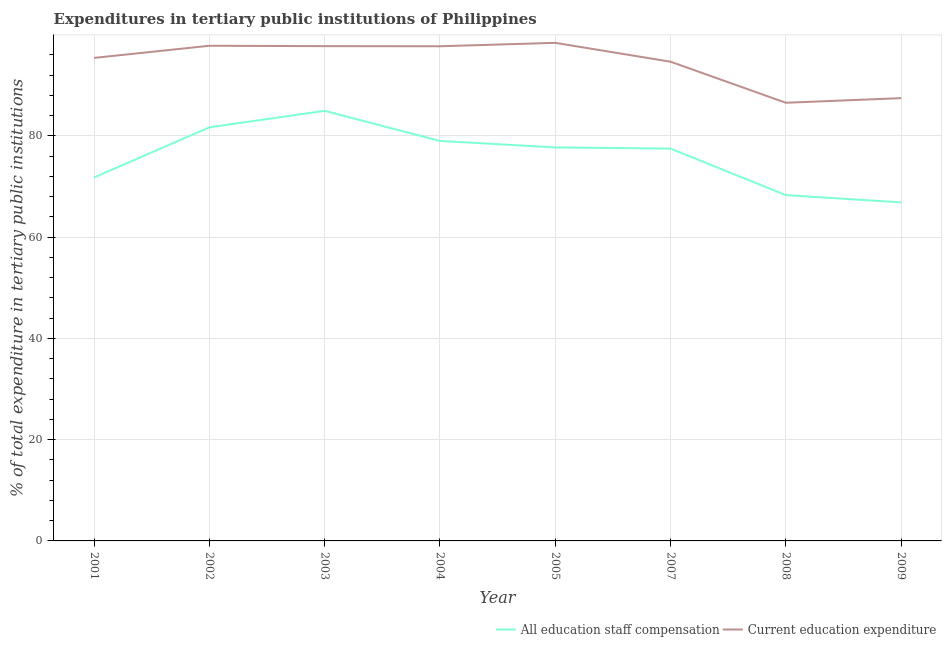Does the line corresponding to expenditure in education intersect with the line corresponding to expenditure in staff compensation?
Provide a succinct answer. No. Is the number of lines equal to the number of legend labels?
Ensure brevity in your answer.  Yes. What is the expenditure in education in 2001?
Your answer should be very brief. 95.41. Across all years, what is the maximum expenditure in education?
Make the answer very short. 98.39. Across all years, what is the minimum expenditure in staff compensation?
Your response must be concise. 66.88. What is the total expenditure in education in the graph?
Provide a short and direct response. 755.74. What is the difference between the expenditure in staff compensation in 2002 and that in 2007?
Keep it short and to the point. 4.2. What is the difference between the expenditure in staff compensation in 2007 and the expenditure in education in 2005?
Ensure brevity in your answer.  -20.89. What is the average expenditure in staff compensation per year?
Your response must be concise. 75.98. In the year 2003, what is the difference between the expenditure in education and expenditure in staff compensation?
Provide a short and direct response. 12.78. What is the ratio of the expenditure in education in 2001 to that in 2005?
Ensure brevity in your answer.  0.97. Is the expenditure in staff compensation in 2002 less than that in 2004?
Provide a succinct answer. No. Is the difference between the expenditure in staff compensation in 2002 and 2003 greater than the difference between the expenditure in education in 2002 and 2003?
Offer a terse response. No. What is the difference between the highest and the second highest expenditure in staff compensation?
Your answer should be very brief. 3.25. What is the difference between the highest and the lowest expenditure in education?
Offer a terse response. 11.84. Is the sum of the expenditure in education in 2004 and 2009 greater than the maximum expenditure in staff compensation across all years?
Your response must be concise. Yes. Does the expenditure in education monotonically increase over the years?
Ensure brevity in your answer.  No. Is the expenditure in education strictly greater than the expenditure in staff compensation over the years?
Your response must be concise. Yes. How many lines are there?
Your answer should be very brief. 2. How many years are there in the graph?
Provide a succinct answer. 8. What is the difference between two consecutive major ticks on the Y-axis?
Ensure brevity in your answer.  20. Are the values on the major ticks of Y-axis written in scientific E-notation?
Offer a terse response. No. Does the graph contain any zero values?
Ensure brevity in your answer.  No. What is the title of the graph?
Provide a succinct answer. Expenditures in tertiary public institutions of Philippines. Does "Working capital" appear as one of the legend labels in the graph?
Keep it short and to the point. No. What is the label or title of the Y-axis?
Make the answer very short. % of total expenditure in tertiary public institutions. What is the % of total expenditure in tertiary public institutions of All education staff compensation in 2001?
Your response must be concise. 71.79. What is the % of total expenditure in tertiary public institutions of Current education expenditure in 2001?
Keep it short and to the point. 95.41. What is the % of total expenditure in tertiary public institutions in All education staff compensation in 2002?
Your answer should be compact. 81.7. What is the % of total expenditure in tertiary public institutions of Current education expenditure in 2002?
Ensure brevity in your answer.  97.81. What is the % of total expenditure in tertiary public institutions in All education staff compensation in 2003?
Provide a succinct answer. 84.95. What is the % of total expenditure in tertiary public institutions in Current education expenditure in 2003?
Offer a terse response. 97.74. What is the % of total expenditure in tertiary public institutions of All education staff compensation in 2004?
Give a very brief answer. 79.01. What is the % of total expenditure in tertiary public institutions in Current education expenditure in 2004?
Ensure brevity in your answer.  97.72. What is the % of total expenditure in tertiary public institutions of All education staff compensation in 2005?
Give a very brief answer. 77.73. What is the % of total expenditure in tertiary public institutions of Current education expenditure in 2005?
Provide a short and direct response. 98.39. What is the % of total expenditure in tertiary public institutions in All education staff compensation in 2007?
Your answer should be compact. 77.5. What is the % of total expenditure in tertiary public institutions in Current education expenditure in 2007?
Offer a terse response. 94.66. What is the % of total expenditure in tertiary public institutions in All education staff compensation in 2008?
Offer a very short reply. 68.31. What is the % of total expenditure in tertiary public institutions of Current education expenditure in 2008?
Your response must be concise. 86.55. What is the % of total expenditure in tertiary public institutions in All education staff compensation in 2009?
Keep it short and to the point. 66.88. What is the % of total expenditure in tertiary public institutions of Current education expenditure in 2009?
Make the answer very short. 87.46. Across all years, what is the maximum % of total expenditure in tertiary public institutions in All education staff compensation?
Your answer should be very brief. 84.95. Across all years, what is the maximum % of total expenditure in tertiary public institutions in Current education expenditure?
Keep it short and to the point. 98.39. Across all years, what is the minimum % of total expenditure in tertiary public institutions of All education staff compensation?
Your response must be concise. 66.88. Across all years, what is the minimum % of total expenditure in tertiary public institutions in Current education expenditure?
Make the answer very short. 86.55. What is the total % of total expenditure in tertiary public institutions of All education staff compensation in the graph?
Your answer should be very brief. 607.87. What is the total % of total expenditure in tertiary public institutions in Current education expenditure in the graph?
Your answer should be compact. 755.74. What is the difference between the % of total expenditure in tertiary public institutions of All education staff compensation in 2001 and that in 2002?
Make the answer very short. -9.91. What is the difference between the % of total expenditure in tertiary public institutions of Current education expenditure in 2001 and that in 2002?
Your answer should be compact. -2.4. What is the difference between the % of total expenditure in tertiary public institutions in All education staff compensation in 2001 and that in 2003?
Your answer should be compact. -13.16. What is the difference between the % of total expenditure in tertiary public institutions in Current education expenditure in 2001 and that in 2003?
Keep it short and to the point. -2.32. What is the difference between the % of total expenditure in tertiary public institutions in All education staff compensation in 2001 and that in 2004?
Your answer should be compact. -7.22. What is the difference between the % of total expenditure in tertiary public institutions in Current education expenditure in 2001 and that in 2004?
Provide a short and direct response. -2.3. What is the difference between the % of total expenditure in tertiary public institutions of All education staff compensation in 2001 and that in 2005?
Ensure brevity in your answer.  -5.94. What is the difference between the % of total expenditure in tertiary public institutions of Current education expenditure in 2001 and that in 2005?
Your response must be concise. -2.97. What is the difference between the % of total expenditure in tertiary public institutions of All education staff compensation in 2001 and that in 2007?
Provide a succinct answer. -5.71. What is the difference between the % of total expenditure in tertiary public institutions in Current education expenditure in 2001 and that in 2007?
Your response must be concise. 0.75. What is the difference between the % of total expenditure in tertiary public institutions of All education staff compensation in 2001 and that in 2008?
Make the answer very short. 3.48. What is the difference between the % of total expenditure in tertiary public institutions in Current education expenditure in 2001 and that in 2008?
Your answer should be very brief. 8.86. What is the difference between the % of total expenditure in tertiary public institutions of All education staff compensation in 2001 and that in 2009?
Provide a succinct answer. 4.92. What is the difference between the % of total expenditure in tertiary public institutions in Current education expenditure in 2001 and that in 2009?
Your answer should be very brief. 7.95. What is the difference between the % of total expenditure in tertiary public institutions of All education staff compensation in 2002 and that in 2003?
Provide a succinct answer. -3.25. What is the difference between the % of total expenditure in tertiary public institutions of Current education expenditure in 2002 and that in 2003?
Provide a succinct answer. 0.07. What is the difference between the % of total expenditure in tertiary public institutions of All education staff compensation in 2002 and that in 2004?
Provide a succinct answer. 2.69. What is the difference between the % of total expenditure in tertiary public institutions of Current education expenditure in 2002 and that in 2004?
Offer a terse response. 0.09. What is the difference between the % of total expenditure in tertiary public institutions in All education staff compensation in 2002 and that in 2005?
Your answer should be very brief. 3.97. What is the difference between the % of total expenditure in tertiary public institutions in Current education expenditure in 2002 and that in 2005?
Provide a succinct answer. -0.58. What is the difference between the % of total expenditure in tertiary public institutions of All education staff compensation in 2002 and that in 2007?
Make the answer very short. 4.2. What is the difference between the % of total expenditure in tertiary public institutions of Current education expenditure in 2002 and that in 2007?
Ensure brevity in your answer.  3.15. What is the difference between the % of total expenditure in tertiary public institutions of All education staff compensation in 2002 and that in 2008?
Offer a terse response. 13.39. What is the difference between the % of total expenditure in tertiary public institutions in Current education expenditure in 2002 and that in 2008?
Your answer should be very brief. 11.26. What is the difference between the % of total expenditure in tertiary public institutions in All education staff compensation in 2002 and that in 2009?
Provide a short and direct response. 14.83. What is the difference between the % of total expenditure in tertiary public institutions in Current education expenditure in 2002 and that in 2009?
Your answer should be very brief. 10.35. What is the difference between the % of total expenditure in tertiary public institutions in All education staff compensation in 2003 and that in 2004?
Offer a terse response. 5.94. What is the difference between the % of total expenditure in tertiary public institutions in Current education expenditure in 2003 and that in 2004?
Your response must be concise. 0.02. What is the difference between the % of total expenditure in tertiary public institutions in All education staff compensation in 2003 and that in 2005?
Make the answer very short. 7.23. What is the difference between the % of total expenditure in tertiary public institutions of Current education expenditure in 2003 and that in 2005?
Give a very brief answer. -0.65. What is the difference between the % of total expenditure in tertiary public institutions of All education staff compensation in 2003 and that in 2007?
Provide a succinct answer. 7.46. What is the difference between the % of total expenditure in tertiary public institutions of Current education expenditure in 2003 and that in 2007?
Your answer should be very brief. 3.07. What is the difference between the % of total expenditure in tertiary public institutions of All education staff compensation in 2003 and that in 2008?
Offer a very short reply. 16.65. What is the difference between the % of total expenditure in tertiary public institutions of Current education expenditure in 2003 and that in 2008?
Offer a very short reply. 11.19. What is the difference between the % of total expenditure in tertiary public institutions in All education staff compensation in 2003 and that in 2009?
Give a very brief answer. 18.08. What is the difference between the % of total expenditure in tertiary public institutions of Current education expenditure in 2003 and that in 2009?
Ensure brevity in your answer.  10.27. What is the difference between the % of total expenditure in tertiary public institutions of All education staff compensation in 2004 and that in 2005?
Your response must be concise. 1.28. What is the difference between the % of total expenditure in tertiary public institutions of Current education expenditure in 2004 and that in 2005?
Your answer should be compact. -0.67. What is the difference between the % of total expenditure in tertiary public institutions in All education staff compensation in 2004 and that in 2007?
Offer a terse response. 1.52. What is the difference between the % of total expenditure in tertiary public institutions of Current education expenditure in 2004 and that in 2007?
Give a very brief answer. 3.05. What is the difference between the % of total expenditure in tertiary public institutions of All education staff compensation in 2004 and that in 2008?
Provide a short and direct response. 10.71. What is the difference between the % of total expenditure in tertiary public institutions of Current education expenditure in 2004 and that in 2008?
Offer a very short reply. 11.17. What is the difference between the % of total expenditure in tertiary public institutions in All education staff compensation in 2004 and that in 2009?
Ensure brevity in your answer.  12.14. What is the difference between the % of total expenditure in tertiary public institutions in Current education expenditure in 2004 and that in 2009?
Ensure brevity in your answer.  10.25. What is the difference between the % of total expenditure in tertiary public institutions in All education staff compensation in 2005 and that in 2007?
Your response must be concise. 0.23. What is the difference between the % of total expenditure in tertiary public institutions of Current education expenditure in 2005 and that in 2007?
Your response must be concise. 3.72. What is the difference between the % of total expenditure in tertiary public institutions in All education staff compensation in 2005 and that in 2008?
Offer a terse response. 9.42. What is the difference between the % of total expenditure in tertiary public institutions in Current education expenditure in 2005 and that in 2008?
Your response must be concise. 11.84. What is the difference between the % of total expenditure in tertiary public institutions of All education staff compensation in 2005 and that in 2009?
Your answer should be very brief. 10.85. What is the difference between the % of total expenditure in tertiary public institutions of Current education expenditure in 2005 and that in 2009?
Provide a short and direct response. 10.92. What is the difference between the % of total expenditure in tertiary public institutions of All education staff compensation in 2007 and that in 2008?
Provide a short and direct response. 9.19. What is the difference between the % of total expenditure in tertiary public institutions in Current education expenditure in 2007 and that in 2008?
Ensure brevity in your answer.  8.11. What is the difference between the % of total expenditure in tertiary public institutions of All education staff compensation in 2007 and that in 2009?
Offer a very short reply. 10.62. What is the difference between the % of total expenditure in tertiary public institutions of Current education expenditure in 2007 and that in 2009?
Your answer should be very brief. 7.2. What is the difference between the % of total expenditure in tertiary public institutions in All education staff compensation in 2008 and that in 2009?
Give a very brief answer. 1.43. What is the difference between the % of total expenditure in tertiary public institutions in Current education expenditure in 2008 and that in 2009?
Make the answer very short. -0.91. What is the difference between the % of total expenditure in tertiary public institutions in All education staff compensation in 2001 and the % of total expenditure in tertiary public institutions in Current education expenditure in 2002?
Your answer should be very brief. -26.02. What is the difference between the % of total expenditure in tertiary public institutions in All education staff compensation in 2001 and the % of total expenditure in tertiary public institutions in Current education expenditure in 2003?
Give a very brief answer. -25.94. What is the difference between the % of total expenditure in tertiary public institutions in All education staff compensation in 2001 and the % of total expenditure in tertiary public institutions in Current education expenditure in 2004?
Your answer should be very brief. -25.92. What is the difference between the % of total expenditure in tertiary public institutions in All education staff compensation in 2001 and the % of total expenditure in tertiary public institutions in Current education expenditure in 2005?
Make the answer very short. -26.59. What is the difference between the % of total expenditure in tertiary public institutions of All education staff compensation in 2001 and the % of total expenditure in tertiary public institutions of Current education expenditure in 2007?
Provide a succinct answer. -22.87. What is the difference between the % of total expenditure in tertiary public institutions in All education staff compensation in 2001 and the % of total expenditure in tertiary public institutions in Current education expenditure in 2008?
Offer a very short reply. -14.76. What is the difference between the % of total expenditure in tertiary public institutions of All education staff compensation in 2001 and the % of total expenditure in tertiary public institutions of Current education expenditure in 2009?
Your response must be concise. -15.67. What is the difference between the % of total expenditure in tertiary public institutions in All education staff compensation in 2002 and the % of total expenditure in tertiary public institutions in Current education expenditure in 2003?
Your response must be concise. -16.04. What is the difference between the % of total expenditure in tertiary public institutions in All education staff compensation in 2002 and the % of total expenditure in tertiary public institutions in Current education expenditure in 2004?
Offer a terse response. -16.01. What is the difference between the % of total expenditure in tertiary public institutions of All education staff compensation in 2002 and the % of total expenditure in tertiary public institutions of Current education expenditure in 2005?
Your answer should be very brief. -16.68. What is the difference between the % of total expenditure in tertiary public institutions of All education staff compensation in 2002 and the % of total expenditure in tertiary public institutions of Current education expenditure in 2007?
Your answer should be very brief. -12.96. What is the difference between the % of total expenditure in tertiary public institutions of All education staff compensation in 2002 and the % of total expenditure in tertiary public institutions of Current education expenditure in 2008?
Your response must be concise. -4.85. What is the difference between the % of total expenditure in tertiary public institutions of All education staff compensation in 2002 and the % of total expenditure in tertiary public institutions of Current education expenditure in 2009?
Keep it short and to the point. -5.76. What is the difference between the % of total expenditure in tertiary public institutions of All education staff compensation in 2003 and the % of total expenditure in tertiary public institutions of Current education expenditure in 2004?
Your answer should be very brief. -12.76. What is the difference between the % of total expenditure in tertiary public institutions in All education staff compensation in 2003 and the % of total expenditure in tertiary public institutions in Current education expenditure in 2005?
Offer a very short reply. -13.43. What is the difference between the % of total expenditure in tertiary public institutions in All education staff compensation in 2003 and the % of total expenditure in tertiary public institutions in Current education expenditure in 2007?
Offer a very short reply. -9.71. What is the difference between the % of total expenditure in tertiary public institutions in All education staff compensation in 2003 and the % of total expenditure in tertiary public institutions in Current education expenditure in 2008?
Your answer should be compact. -1.6. What is the difference between the % of total expenditure in tertiary public institutions in All education staff compensation in 2003 and the % of total expenditure in tertiary public institutions in Current education expenditure in 2009?
Your response must be concise. -2.51. What is the difference between the % of total expenditure in tertiary public institutions in All education staff compensation in 2004 and the % of total expenditure in tertiary public institutions in Current education expenditure in 2005?
Keep it short and to the point. -19.37. What is the difference between the % of total expenditure in tertiary public institutions in All education staff compensation in 2004 and the % of total expenditure in tertiary public institutions in Current education expenditure in 2007?
Ensure brevity in your answer.  -15.65. What is the difference between the % of total expenditure in tertiary public institutions in All education staff compensation in 2004 and the % of total expenditure in tertiary public institutions in Current education expenditure in 2008?
Make the answer very short. -7.54. What is the difference between the % of total expenditure in tertiary public institutions in All education staff compensation in 2004 and the % of total expenditure in tertiary public institutions in Current education expenditure in 2009?
Your answer should be compact. -8.45. What is the difference between the % of total expenditure in tertiary public institutions of All education staff compensation in 2005 and the % of total expenditure in tertiary public institutions of Current education expenditure in 2007?
Your answer should be compact. -16.93. What is the difference between the % of total expenditure in tertiary public institutions of All education staff compensation in 2005 and the % of total expenditure in tertiary public institutions of Current education expenditure in 2008?
Provide a succinct answer. -8.82. What is the difference between the % of total expenditure in tertiary public institutions of All education staff compensation in 2005 and the % of total expenditure in tertiary public institutions of Current education expenditure in 2009?
Your response must be concise. -9.74. What is the difference between the % of total expenditure in tertiary public institutions in All education staff compensation in 2007 and the % of total expenditure in tertiary public institutions in Current education expenditure in 2008?
Provide a succinct answer. -9.05. What is the difference between the % of total expenditure in tertiary public institutions of All education staff compensation in 2007 and the % of total expenditure in tertiary public institutions of Current education expenditure in 2009?
Offer a terse response. -9.97. What is the difference between the % of total expenditure in tertiary public institutions in All education staff compensation in 2008 and the % of total expenditure in tertiary public institutions in Current education expenditure in 2009?
Offer a terse response. -19.16. What is the average % of total expenditure in tertiary public institutions in All education staff compensation per year?
Give a very brief answer. 75.98. What is the average % of total expenditure in tertiary public institutions of Current education expenditure per year?
Make the answer very short. 94.47. In the year 2001, what is the difference between the % of total expenditure in tertiary public institutions of All education staff compensation and % of total expenditure in tertiary public institutions of Current education expenditure?
Give a very brief answer. -23.62. In the year 2002, what is the difference between the % of total expenditure in tertiary public institutions in All education staff compensation and % of total expenditure in tertiary public institutions in Current education expenditure?
Offer a terse response. -16.11. In the year 2003, what is the difference between the % of total expenditure in tertiary public institutions in All education staff compensation and % of total expenditure in tertiary public institutions in Current education expenditure?
Give a very brief answer. -12.78. In the year 2004, what is the difference between the % of total expenditure in tertiary public institutions of All education staff compensation and % of total expenditure in tertiary public institutions of Current education expenditure?
Offer a terse response. -18.7. In the year 2005, what is the difference between the % of total expenditure in tertiary public institutions of All education staff compensation and % of total expenditure in tertiary public institutions of Current education expenditure?
Ensure brevity in your answer.  -20.66. In the year 2007, what is the difference between the % of total expenditure in tertiary public institutions in All education staff compensation and % of total expenditure in tertiary public institutions in Current education expenditure?
Keep it short and to the point. -17.16. In the year 2008, what is the difference between the % of total expenditure in tertiary public institutions in All education staff compensation and % of total expenditure in tertiary public institutions in Current education expenditure?
Offer a terse response. -18.24. In the year 2009, what is the difference between the % of total expenditure in tertiary public institutions in All education staff compensation and % of total expenditure in tertiary public institutions in Current education expenditure?
Keep it short and to the point. -20.59. What is the ratio of the % of total expenditure in tertiary public institutions in All education staff compensation in 2001 to that in 2002?
Provide a succinct answer. 0.88. What is the ratio of the % of total expenditure in tertiary public institutions in Current education expenditure in 2001 to that in 2002?
Your answer should be very brief. 0.98. What is the ratio of the % of total expenditure in tertiary public institutions in All education staff compensation in 2001 to that in 2003?
Offer a terse response. 0.85. What is the ratio of the % of total expenditure in tertiary public institutions of Current education expenditure in 2001 to that in 2003?
Make the answer very short. 0.98. What is the ratio of the % of total expenditure in tertiary public institutions in All education staff compensation in 2001 to that in 2004?
Make the answer very short. 0.91. What is the ratio of the % of total expenditure in tertiary public institutions in Current education expenditure in 2001 to that in 2004?
Your answer should be compact. 0.98. What is the ratio of the % of total expenditure in tertiary public institutions in All education staff compensation in 2001 to that in 2005?
Your response must be concise. 0.92. What is the ratio of the % of total expenditure in tertiary public institutions in Current education expenditure in 2001 to that in 2005?
Offer a very short reply. 0.97. What is the ratio of the % of total expenditure in tertiary public institutions of All education staff compensation in 2001 to that in 2007?
Your response must be concise. 0.93. What is the ratio of the % of total expenditure in tertiary public institutions in Current education expenditure in 2001 to that in 2007?
Offer a very short reply. 1.01. What is the ratio of the % of total expenditure in tertiary public institutions of All education staff compensation in 2001 to that in 2008?
Offer a terse response. 1.05. What is the ratio of the % of total expenditure in tertiary public institutions of Current education expenditure in 2001 to that in 2008?
Give a very brief answer. 1.1. What is the ratio of the % of total expenditure in tertiary public institutions in All education staff compensation in 2001 to that in 2009?
Your answer should be compact. 1.07. What is the ratio of the % of total expenditure in tertiary public institutions in Current education expenditure in 2001 to that in 2009?
Your answer should be compact. 1.09. What is the ratio of the % of total expenditure in tertiary public institutions in All education staff compensation in 2002 to that in 2003?
Offer a very short reply. 0.96. What is the ratio of the % of total expenditure in tertiary public institutions in All education staff compensation in 2002 to that in 2004?
Provide a succinct answer. 1.03. What is the ratio of the % of total expenditure in tertiary public institutions in Current education expenditure in 2002 to that in 2004?
Ensure brevity in your answer.  1. What is the ratio of the % of total expenditure in tertiary public institutions of All education staff compensation in 2002 to that in 2005?
Your answer should be compact. 1.05. What is the ratio of the % of total expenditure in tertiary public institutions of Current education expenditure in 2002 to that in 2005?
Provide a succinct answer. 0.99. What is the ratio of the % of total expenditure in tertiary public institutions in All education staff compensation in 2002 to that in 2007?
Make the answer very short. 1.05. What is the ratio of the % of total expenditure in tertiary public institutions in All education staff compensation in 2002 to that in 2008?
Provide a succinct answer. 1.2. What is the ratio of the % of total expenditure in tertiary public institutions in Current education expenditure in 2002 to that in 2008?
Make the answer very short. 1.13. What is the ratio of the % of total expenditure in tertiary public institutions in All education staff compensation in 2002 to that in 2009?
Offer a very short reply. 1.22. What is the ratio of the % of total expenditure in tertiary public institutions in Current education expenditure in 2002 to that in 2009?
Ensure brevity in your answer.  1.12. What is the ratio of the % of total expenditure in tertiary public institutions in All education staff compensation in 2003 to that in 2004?
Your answer should be compact. 1.08. What is the ratio of the % of total expenditure in tertiary public institutions of All education staff compensation in 2003 to that in 2005?
Ensure brevity in your answer.  1.09. What is the ratio of the % of total expenditure in tertiary public institutions in All education staff compensation in 2003 to that in 2007?
Give a very brief answer. 1.1. What is the ratio of the % of total expenditure in tertiary public institutions in Current education expenditure in 2003 to that in 2007?
Your response must be concise. 1.03. What is the ratio of the % of total expenditure in tertiary public institutions in All education staff compensation in 2003 to that in 2008?
Keep it short and to the point. 1.24. What is the ratio of the % of total expenditure in tertiary public institutions in Current education expenditure in 2003 to that in 2008?
Your response must be concise. 1.13. What is the ratio of the % of total expenditure in tertiary public institutions of All education staff compensation in 2003 to that in 2009?
Offer a very short reply. 1.27. What is the ratio of the % of total expenditure in tertiary public institutions in Current education expenditure in 2003 to that in 2009?
Your answer should be compact. 1.12. What is the ratio of the % of total expenditure in tertiary public institutions of All education staff compensation in 2004 to that in 2005?
Provide a succinct answer. 1.02. What is the ratio of the % of total expenditure in tertiary public institutions in Current education expenditure in 2004 to that in 2005?
Give a very brief answer. 0.99. What is the ratio of the % of total expenditure in tertiary public institutions of All education staff compensation in 2004 to that in 2007?
Your answer should be compact. 1.02. What is the ratio of the % of total expenditure in tertiary public institutions in Current education expenditure in 2004 to that in 2007?
Offer a terse response. 1.03. What is the ratio of the % of total expenditure in tertiary public institutions of All education staff compensation in 2004 to that in 2008?
Offer a terse response. 1.16. What is the ratio of the % of total expenditure in tertiary public institutions of Current education expenditure in 2004 to that in 2008?
Offer a terse response. 1.13. What is the ratio of the % of total expenditure in tertiary public institutions of All education staff compensation in 2004 to that in 2009?
Offer a very short reply. 1.18. What is the ratio of the % of total expenditure in tertiary public institutions of Current education expenditure in 2004 to that in 2009?
Offer a terse response. 1.12. What is the ratio of the % of total expenditure in tertiary public institutions of All education staff compensation in 2005 to that in 2007?
Your response must be concise. 1. What is the ratio of the % of total expenditure in tertiary public institutions in Current education expenditure in 2005 to that in 2007?
Keep it short and to the point. 1.04. What is the ratio of the % of total expenditure in tertiary public institutions of All education staff compensation in 2005 to that in 2008?
Make the answer very short. 1.14. What is the ratio of the % of total expenditure in tertiary public institutions in Current education expenditure in 2005 to that in 2008?
Ensure brevity in your answer.  1.14. What is the ratio of the % of total expenditure in tertiary public institutions of All education staff compensation in 2005 to that in 2009?
Provide a short and direct response. 1.16. What is the ratio of the % of total expenditure in tertiary public institutions in Current education expenditure in 2005 to that in 2009?
Your answer should be very brief. 1.12. What is the ratio of the % of total expenditure in tertiary public institutions in All education staff compensation in 2007 to that in 2008?
Give a very brief answer. 1.13. What is the ratio of the % of total expenditure in tertiary public institutions of Current education expenditure in 2007 to that in 2008?
Offer a very short reply. 1.09. What is the ratio of the % of total expenditure in tertiary public institutions of All education staff compensation in 2007 to that in 2009?
Offer a very short reply. 1.16. What is the ratio of the % of total expenditure in tertiary public institutions in Current education expenditure in 2007 to that in 2009?
Offer a very short reply. 1.08. What is the ratio of the % of total expenditure in tertiary public institutions in All education staff compensation in 2008 to that in 2009?
Offer a very short reply. 1.02. What is the ratio of the % of total expenditure in tertiary public institutions of Current education expenditure in 2008 to that in 2009?
Ensure brevity in your answer.  0.99. What is the difference between the highest and the second highest % of total expenditure in tertiary public institutions of All education staff compensation?
Ensure brevity in your answer.  3.25. What is the difference between the highest and the second highest % of total expenditure in tertiary public institutions in Current education expenditure?
Provide a short and direct response. 0.58. What is the difference between the highest and the lowest % of total expenditure in tertiary public institutions of All education staff compensation?
Your response must be concise. 18.08. What is the difference between the highest and the lowest % of total expenditure in tertiary public institutions in Current education expenditure?
Offer a terse response. 11.84. 